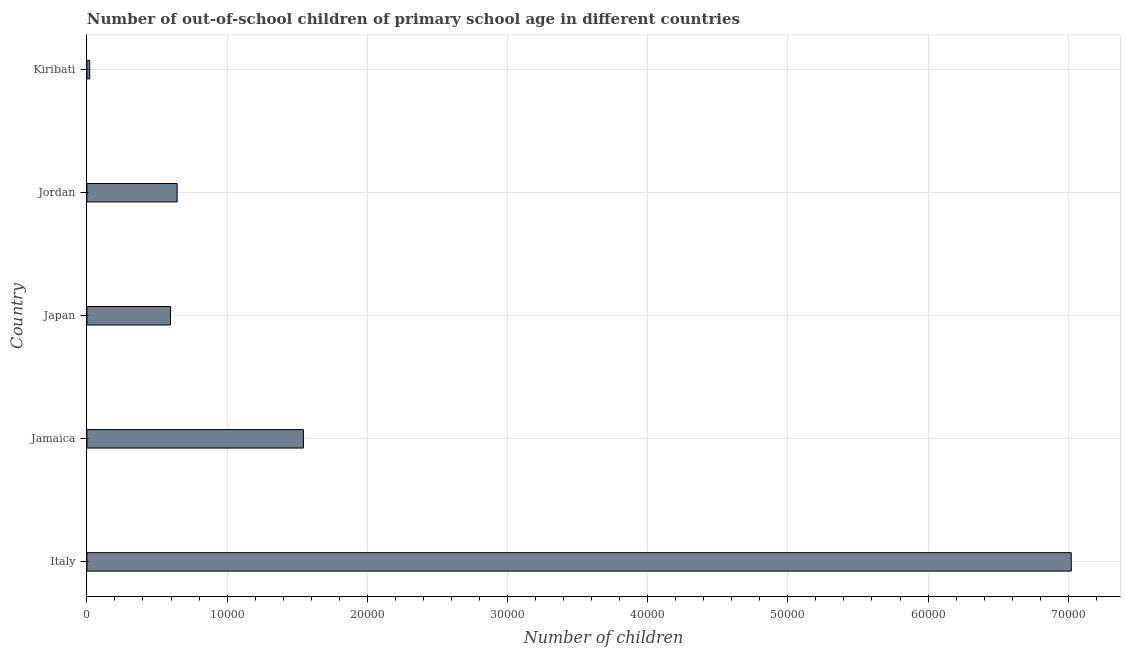What is the title of the graph?
Keep it short and to the point. Number of out-of-school children of primary school age in different countries. What is the label or title of the X-axis?
Keep it short and to the point. Number of children. What is the label or title of the Y-axis?
Give a very brief answer. Country. What is the number of out-of-school children in Kiribati?
Give a very brief answer. 199. Across all countries, what is the maximum number of out-of-school children?
Ensure brevity in your answer.  7.02e+04. Across all countries, what is the minimum number of out-of-school children?
Provide a succinct answer. 199. In which country was the number of out-of-school children minimum?
Offer a terse response. Kiribati. What is the sum of the number of out-of-school children?
Provide a short and direct response. 9.83e+04. What is the difference between the number of out-of-school children in Italy and Jordan?
Your answer should be compact. 6.38e+04. What is the average number of out-of-school children per country?
Make the answer very short. 1.97e+04. What is the median number of out-of-school children?
Offer a terse response. 6436. What is the ratio of the number of out-of-school children in Japan to that in Jordan?
Give a very brief answer. 0.93. What is the difference between the highest and the second highest number of out-of-school children?
Your answer should be very brief. 5.48e+04. What is the difference between the highest and the lowest number of out-of-school children?
Make the answer very short. 7.00e+04. How many bars are there?
Make the answer very short. 5. Are all the bars in the graph horizontal?
Make the answer very short. Yes. What is the difference between two consecutive major ticks on the X-axis?
Your response must be concise. 10000. What is the Number of children in Italy?
Give a very brief answer. 7.02e+04. What is the Number of children of Jamaica?
Offer a terse response. 1.54e+04. What is the Number of children of Japan?
Offer a very short reply. 5959. What is the Number of children in Jordan?
Offer a terse response. 6436. What is the Number of children in Kiribati?
Offer a very short reply. 199. What is the difference between the Number of children in Italy and Jamaica?
Provide a short and direct response. 5.48e+04. What is the difference between the Number of children in Italy and Japan?
Provide a succinct answer. 6.43e+04. What is the difference between the Number of children in Italy and Jordan?
Offer a terse response. 6.38e+04. What is the difference between the Number of children in Italy and Kiribati?
Your answer should be compact. 7.00e+04. What is the difference between the Number of children in Jamaica and Japan?
Provide a succinct answer. 9485. What is the difference between the Number of children in Jamaica and Jordan?
Ensure brevity in your answer.  9008. What is the difference between the Number of children in Jamaica and Kiribati?
Offer a terse response. 1.52e+04. What is the difference between the Number of children in Japan and Jordan?
Make the answer very short. -477. What is the difference between the Number of children in Japan and Kiribati?
Your answer should be compact. 5760. What is the difference between the Number of children in Jordan and Kiribati?
Your answer should be compact. 6237. What is the ratio of the Number of children in Italy to that in Jamaica?
Give a very brief answer. 4.55. What is the ratio of the Number of children in Italy to that in Japan?
Give a very brief answer. 11.78. What is the ratio of the Number of children in Italy to that in Jordan?
Ensure brevity in your answer.  10.91. What is the ratio of the Number of children in Italy to that in Kiribati?
Provide a short and direct response. 352.85. What is the ratio of the Number of children in Jamaica to that in Japan?
Offer a very short reply. 2.59. What is the ratio of the Number of children in Jamaica to that in Jordan?
Your answer should be compact. 2.4. What is the ratio of the Number of children in Jamaica to that in Kiribati?
Your response must be concise. 77.61. What is the ratio of the Number of children in Japan to that in Jordan?
Keep it short and to the point. 0.93. What is the ratio of the Number of children in Japan to that in Kiribati?
Provide a short and direct response. 29.95. What is the ratio of the Number of children in Jordan to that in Kiribati?
Keep it short and to the point. 32.34. 